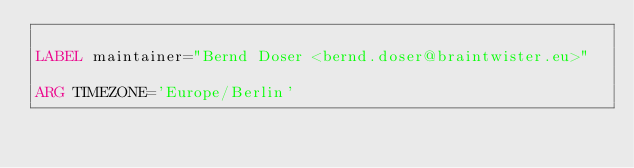<code> <loc_0><loc_0><loc_500><loc_500><_Dockerfile_>
LABEL maintainer="Bernd Doser <bernd.doser@braintwister.eu>"

ARG TIMEZONE='Europe/Berlin'</code> 